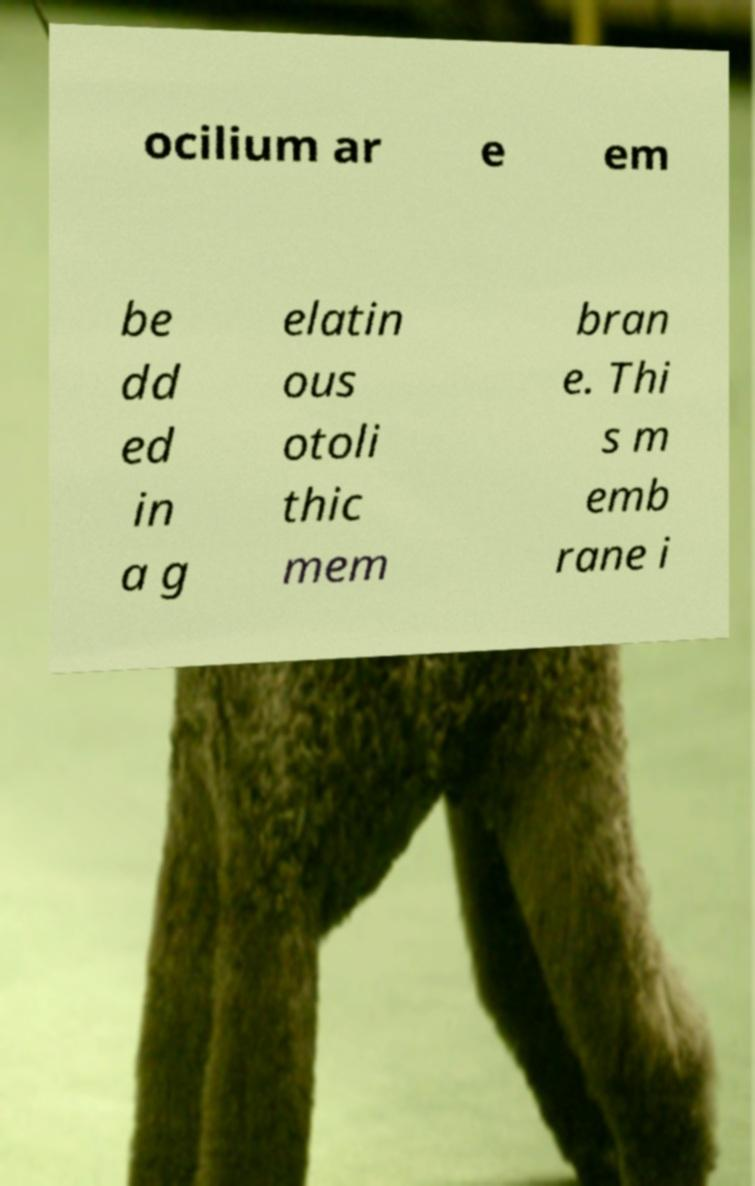Please identify and transcribe the text found in this image. ocilium ar e em be dd ed in a g elatin ous otoli thic mem bran e. Thi s m emb rane i 